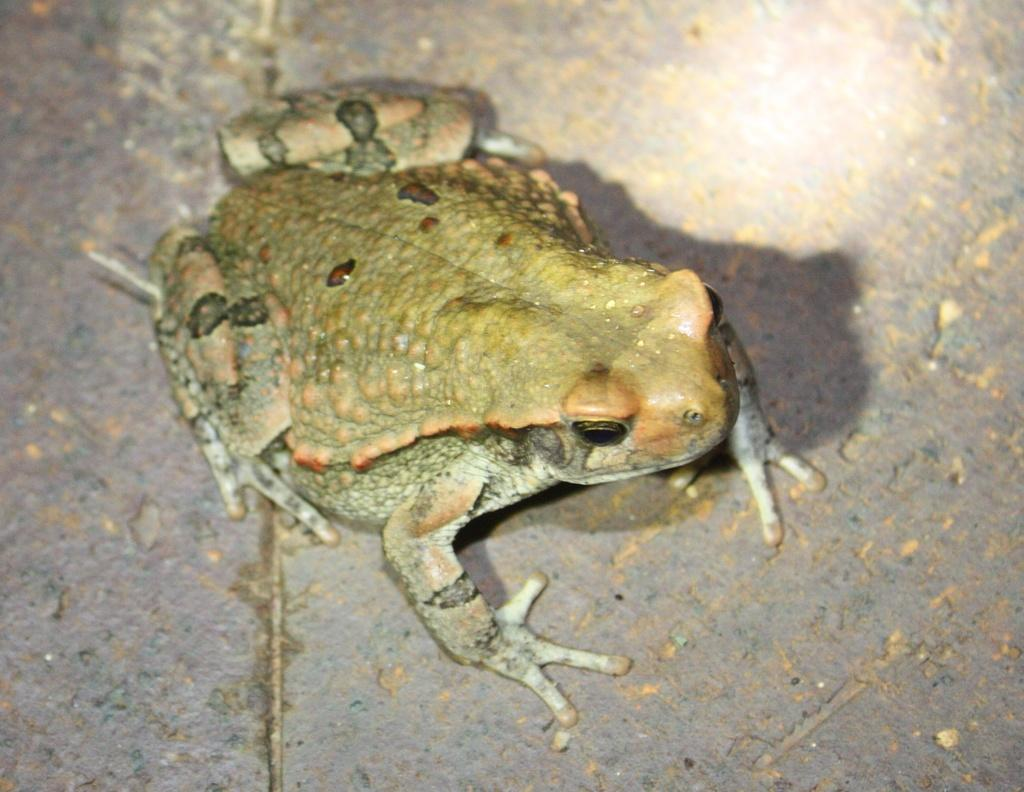What animal is present in the image? There is a frog in the image. Where is the frog located in the image? The frog is on the floor. What type of noise is the frog making in the image? There is no indication of any noise in the image, and we cannot determine if the frog is making any noise. 